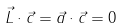Convert formula to latex. <formula><loc_0><loc_0><loc_500><loc_500>\vec { L } \cdot \vec { c } = \vec { a } \cdot \vec { c } = 0</formula> 